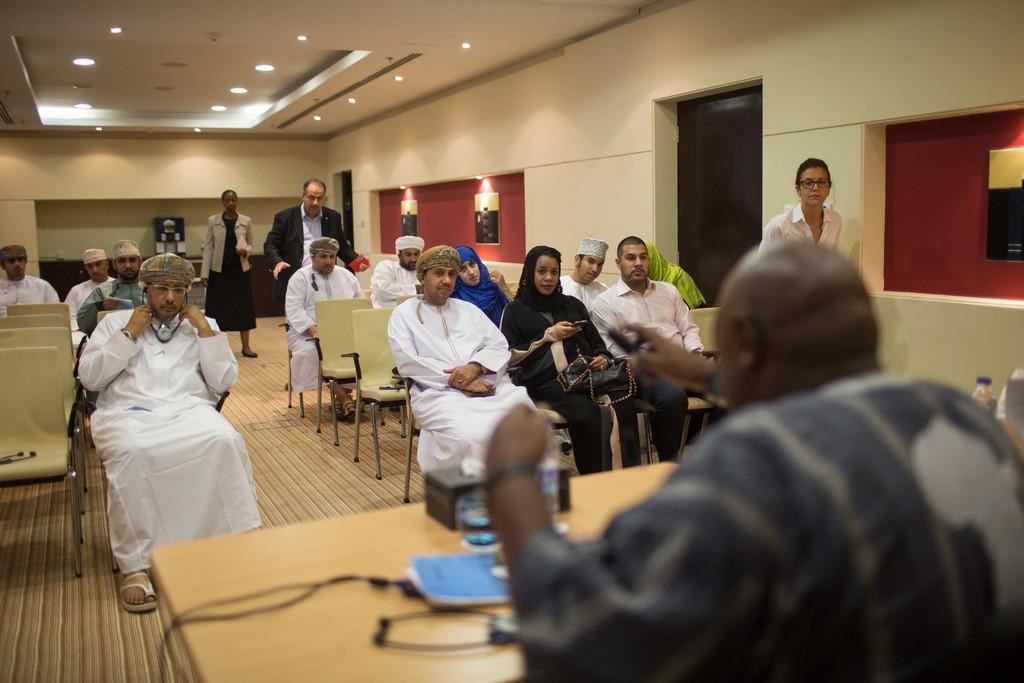In one or two sentences, can you explain what this image depicts? On the right side of the image we can see one person sitting. In front of him, there is a table. On the table, we can see one link box, wires, water bottles and a few other objects. In the center of the image we can see a few people are sitting on the chairs. Among them, few people are holding some objects. In the background there is a wall, lights, frame, one door, a few people are standing and a few other objects. 